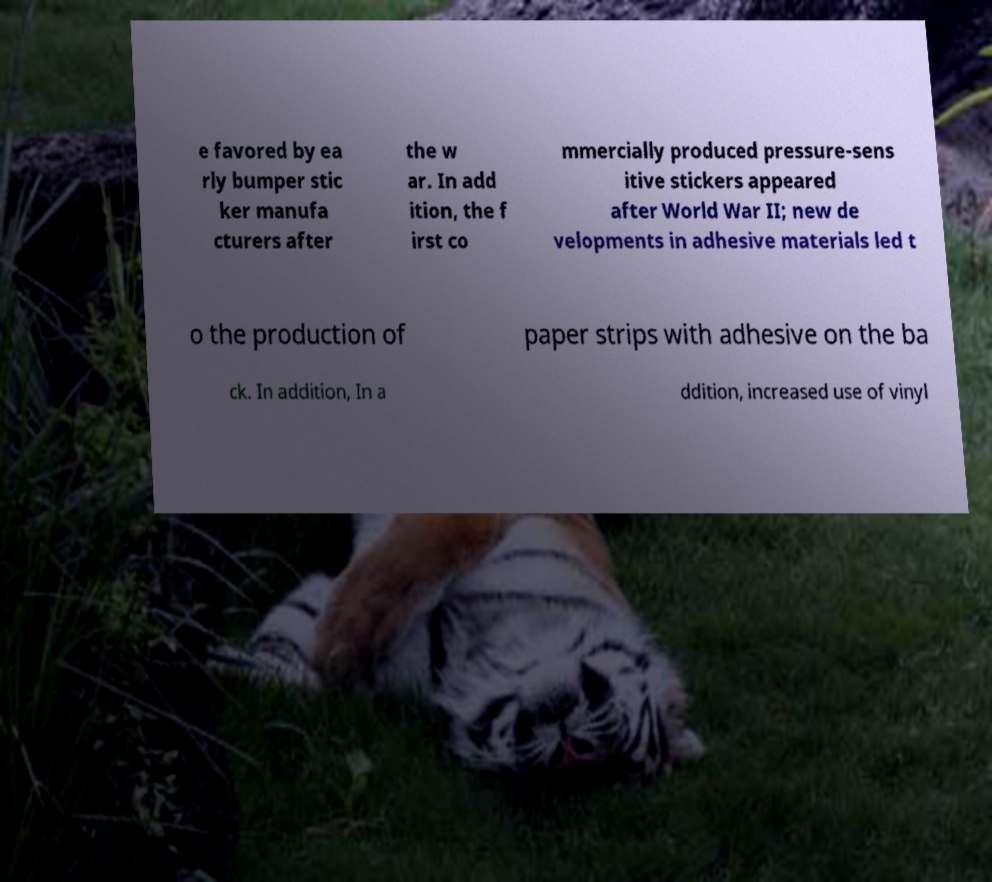There's text embedded in this image that I need extracted. Can you transcribe it verbatim? e favored by ea rly bumper stic ker manufa cturers after the w ar. In add ition, the f irst co mmercially produced pressure-sens itive stickers appeared after World War II; new de velopments in adhesive materials led t o the production of paper strips with adhesive on the ba ck. In addition, In a ddition, increased use of vinyl 